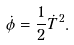Convert formula to latex. <formula><loc_0><loc_0><loc_500><loc_500>\dot { \phi } = \frac { 1 } { 2 } \dot { T } ^ { 2 } .</formula> 